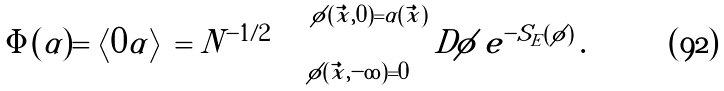<formula> <loc_0><loc_0><loc_500><loc_500>\Phi ( \alpha ) = \left < 0 | \alpha \right > = N ^ { - 1 / 2 } \int _ { \phi ( \vec { x } , - \infty ) = 0 } ^ { \phi ( \vec { x } , 0 ) = \alpha ( \vec { x } ) } D \phi \, e ^ { - S _ { E } ( \phi ) } \, .</formula> 